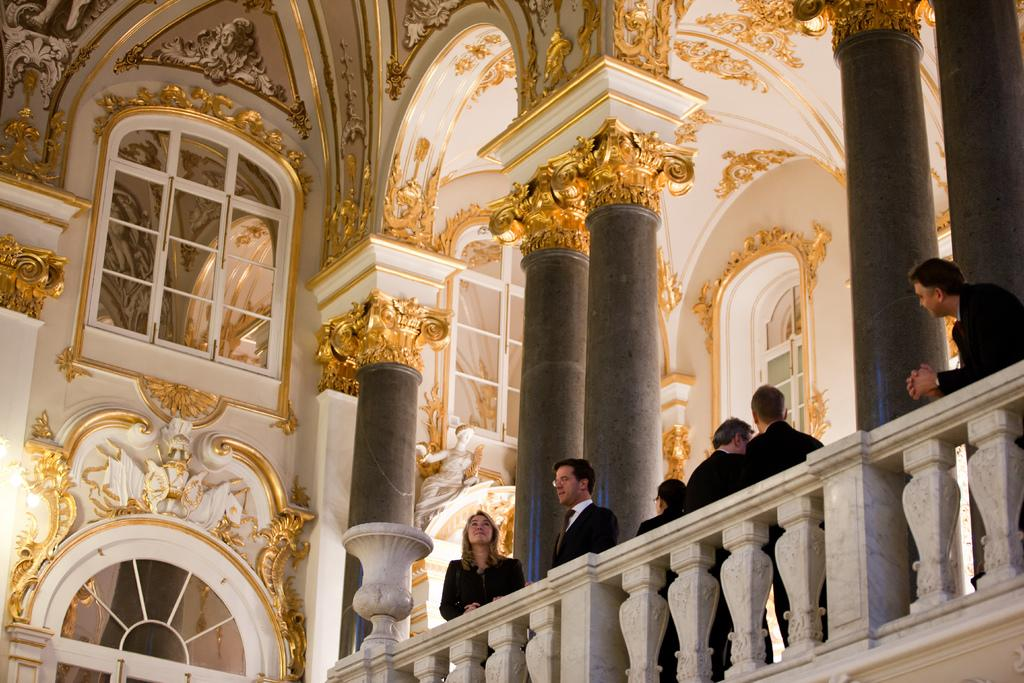What type of location is depicted in the image? The image is an inside picture of a building. Can you describe the people in the image? There are people standing in the image, standing on a veranda. What architectural features are visible in the image? There are pillars visible in the image. What decorative elements can be seen on the walls? There are sculptures on the walls. What allows natural light to enter the building in the image? There are windows in the image. What time of day is it in the image, as indicated by the morning light? The provided facts do not mention anything about the time of day or the presence of morning light in the image. 